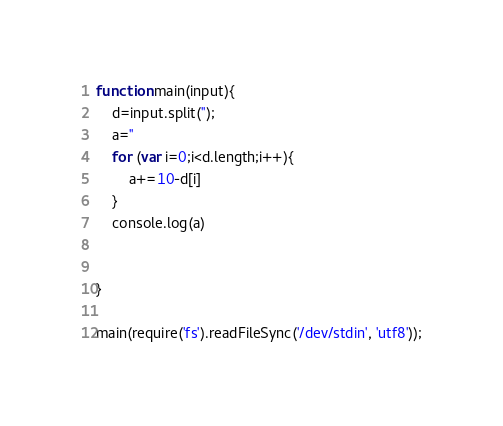Convert code to text. <code><loc_0><loc_0><loc_500><loc_500><_JavaScript_>
function main(input){
    d=input.split('');
    a=''
    for (var i=0;i<d.length;i++){
        a+=10-d[i]
    }
    console.log(a)


}

main(require('fs').readFileSync('/dev/stdin', 'utf8'));</code> 